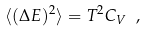<formula> <loc_0><loc_0><loc_500><loc_500>\langle ( \Delta E ) ^ { 2 } \rangle = T ^ { 2 } C _ { V } \ ,</formula> 